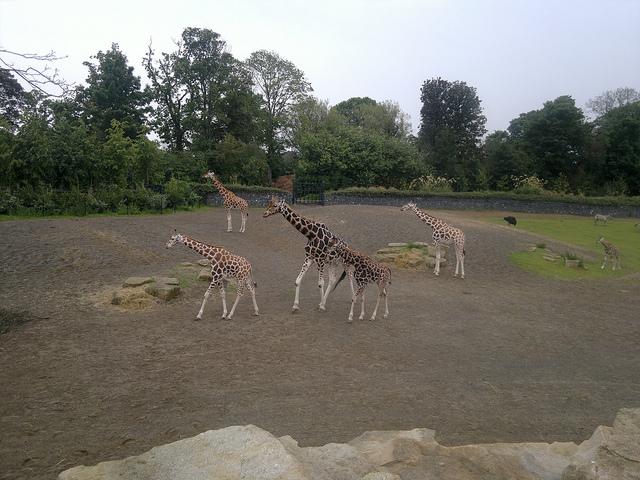What kind of animal is on the beach?
Answer briefly. Giraffe. What kind of animal is in the photo?
Answer briefly. Giraffe. How many lions in the picture?
Short answer required. 0. How many giraffes are there?
Keep it brief. 5. Are majority of the giraffes standing on grass?
Concise answer only. No. 